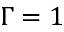Convert formula to latex. <formula><loc_0><loc_0><loc_500><loc_500>\Gamma = 1</formula> 